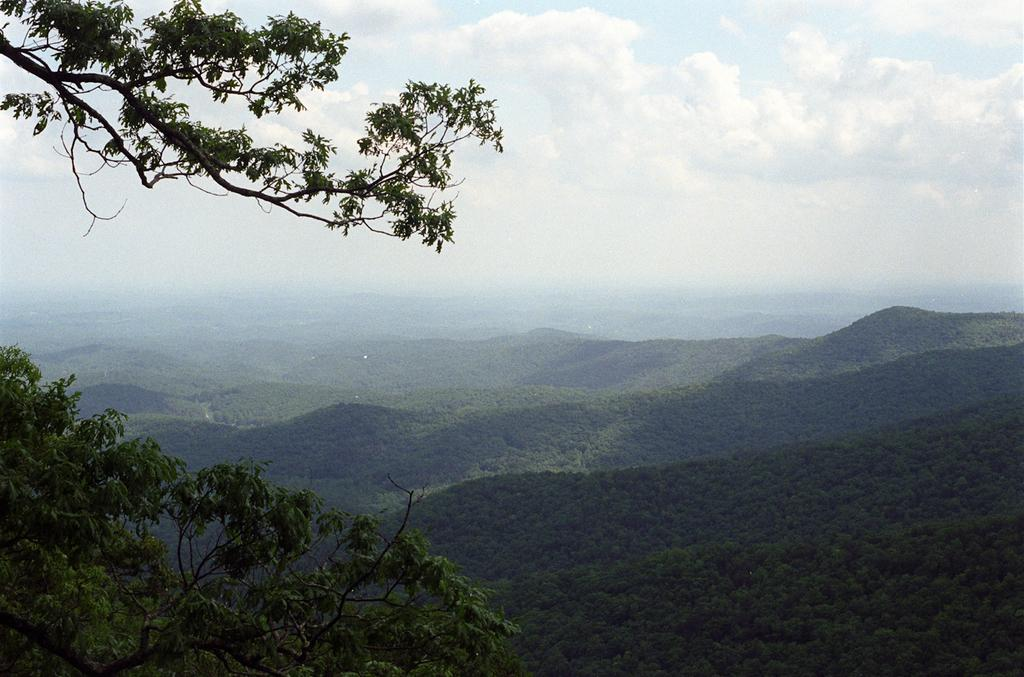What is at the top of the image? There is a branch of a tree at the top of the image. What can be seen in the sky in the image? There are clouds in the sky. What type of vegetation is present in the image? There are trees in the image. What geographical feature is visible in the image? There are mountains in the image. Where is the watch located in the image? There is no watch present in the image. What type of vase can be seen in the wilderness in the image? There is no vase or wilderness present in the image. 